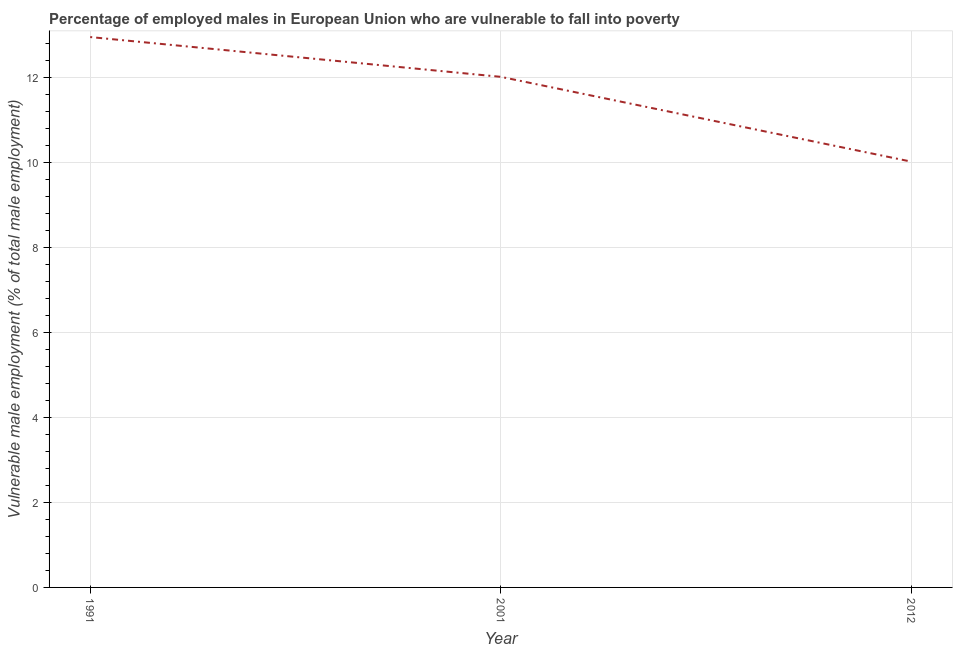What is the percentage of employed males who are vulnerable to fall into poverty in 2001?
Ensure brevity in your answer.  12.02. Across all years, what is the maximum percentage of employed males who are vulnerable to fall into poverty?
Provide a succinct answer. 12.96. Across all years, what is the minimum percentage of employed males who are vulnerable to fall into poverty?
Keep it short and to the point. 10.03. In which year was the percentage of employed males who are vulnerable to fall into poverty maximum?
Make the answer very short. 1991. In which year was the percentage of employed males who are vulnerable to fall into poverty minimum?
Provide a succinct answer. 2012. What is the sum of the percentage of employed males who are vulnerable to fall into poverty?
Give a very brief answer. 35.01. What is the difference between the percentage of employed males who are vulnerable to fall into poverty in 1991 and 2012?
Your answer should be very brief. 2.93. What is the average percentage of employed males who are vulnerable to fall into poverty per year?
Make the answer very short. 11.67. What is the median percentage of employed males who are vulnerable to fall into poverty?
Your answer should be compact. 12.02. In how many years, is the percentage of employed males who are vulnerable to fall into poverty greater than 6 %?
Your response must be concise. 3. What is the ratio of the percentage of employed males who are vulnerable to fall into poverty in 2001 to that in 2012?
Your answer should be very brief. 1.2. What is the difference between the highest and the second highest percentage of employed males who are vulnerable to fall into poverty?
Offer a terse response. 0.94. Is the sum of the percentage of employed males who are vulnerable to fall into poverty in 1991 and 2001 greater than the maximum percentage of employed males who are vulnerable to fall into poverty across all years?
Your answer should be compact. Yes. What is the difference between the highest and the lowest percentage of employed males who are vulnerable to fall into poverty?
Offer a terse response. 2.93. In how many years, is the percentage of employed males who are vulnerable to fall into poverty greater than the average percentage of employed males who are vulnerable to fall into poverty taken over all years?
Offer a terse response. 2. Does the percentage of employed males who are vulnerable to fall into poverty monotonically increase over the years?
Provide a succinct answer. No. What is the difference between two consecutive major ticks on the Y-axis?
Keep it short and to the point. 2. Are the values on the major ticks of Y-axis written in scientific E-notation?
Keep it short and to the point. No. Does the graph contain any zero values?
Your answer should be very brief. No. What is the title of the graph?
Your response must be concise. Percentage of employed males in European Union who are vulnerable to fall into poverty. What is the label or title of the Y-axis?
Ensure brevity in your answer.  Vulnerable male employment (% of total male employment). What is the Vulnerable male employment (% of total male employment) in 1991?
Your response must be concise. 12.96. What is the Vulnerable male employment (% of total male employment) of 2001?
Ensure brevity in your answer.  12.02. What is the Vulnerable male employment (% of total male employment) in 2012?
Keep it short and to the point. 10.03. What is the difference between the Vulnerable male employment (% of total male employment) in 1991 and 2001?
Make the answer very short. 0.94. What is the difference between the Vulnerable male employment (% of total male employment) in 1991 and 2012?
Offer a terse response. 2.93. What is the difference between the Vulnerable male employment (% of total male employment) in 2001 and 2012?
Make the answer very short. 2. What is the ratio of the Vulnerable male employment (% of total male employment) in 1991 to that in 2001?
Give a very brief answer. 1.08. What is the ratio of the Vulnerable male employment (% of total male employment) in 1991 to that in 2012?
Offer a terse response. 1.29. What is the ratio of the Vulnerable male employment (% of total male employment) in 2001 to that in 2012?
Offer a very short reply. 1.2. 